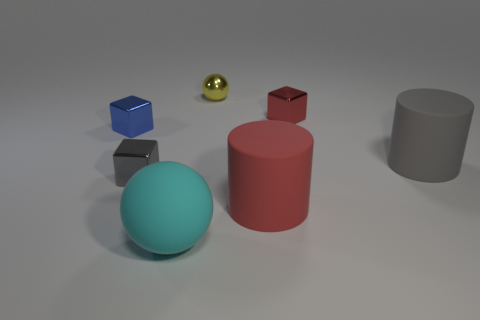How many red rubber cylinders are left of the big rubber object that is behind the metallic object that is in front of the small blue object?
Give a very brief answer. 1. How many things are behind the tiny red metallic cube and left of the large cyan rubber thing?
Provide a short and direct response. 0. Does the yellow object have the same material as the gray block?
Give a very brief answer. Yes. The thing on the right side of the cube that is to the right of the cube that is in front of the small blue thing is what shape?
Your response must be concise. Cylinder. Are there fewer cyan matte spheres right of the tiny sphere than tiny yellow objects that are in front of the blue thing?
Your answer should be compact. No. What shape is the small object that is behind the tiny metal cube that is on the right side of the large sphere?
Offer a terse response. Sphere. Are there any other things that have the same color as the matte sphere?
Your answer should be compact. No. Do the small metal ball and the matte sphere have the same color?
Your answer should be compact. No. What number of yellow things are large cylinders or large rubber things?
Make the answer very short. 0. Are there fewer cyan things to the left of the cyan sphere than big red metal cylinders?
Make the answer very short. No. 